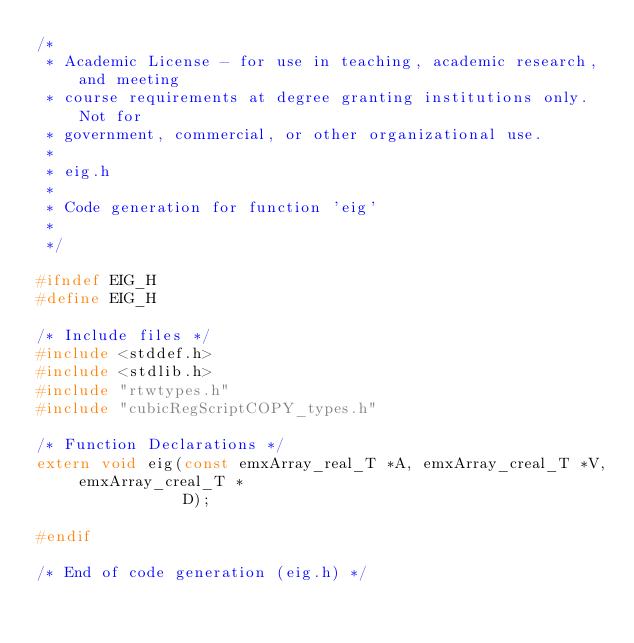<code> <loc_0><loc_0><loc_500><loc_500><_C_>/*
 * Academic License - for use in teaching, academic research, and meeting
 * course requirements at degree granting institutions only.  Not for
 * government, commercial, or other organizational use.
 *
 * eig.h
 *
 * Code generation for function 'eig'
 *
 */

#ifndef EIG_H
#define EIG_H

/* Include files */
#include <stddef.h>
#include <stdlib.h>
#include "rtwtypes.h"
#include "cubicRegScriptCOPY_types.h"

/* Function Declarations */
extern void eig(const emxArray_real_T *A, emxArray_creal_T *V, emxArray_creal_T *
                D);

#endif

/* End of code generation (eig.h) */
</code> 